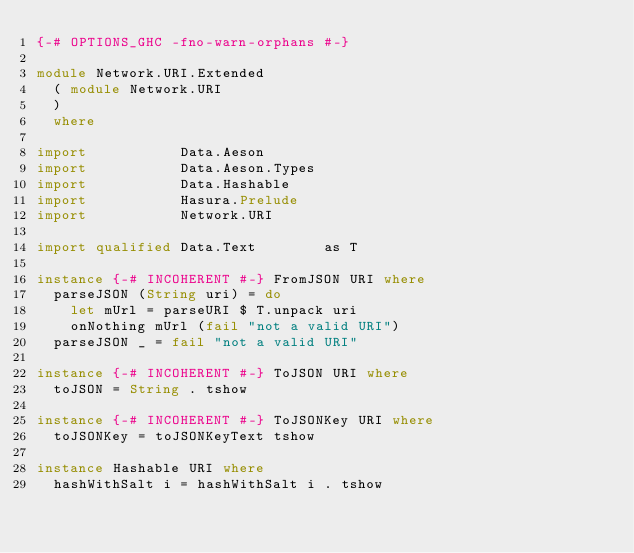<code> <loc_0><loc_0><loc_500><loc_500><_Haskell_>{-# OPTIONS_GHC -fno-warn-orphans #-}

module Network.URI.Extended
  ( module Network.URI
  )
  where

import           Data.Aeson
import           Data.Aeson.Types
import           Data.Hashable
import           Hasura.Prelude
import           Network.URI

import qualified Data.Text        as T

instance {-# INCOHERENT #-} FromJSON URI where
  parseJSON (String uri) = do
    let mUrl = parseURI $ T.unpack uri
    onNothing mUrl (fail "not a valid URI")
  parseJSON _ = fail "not a valid URI"

instance {-# INCOHERENT #-} ToJSON URI where
  toJSON = String . tshow

instance {-# INCOHERENT #-} ToJSONKey URI where
  toJSONKey = toJSONKeyText tshow

instance Hashable URI where
  hashWithSalt i = hashWithSalt i . tshow
</code> 